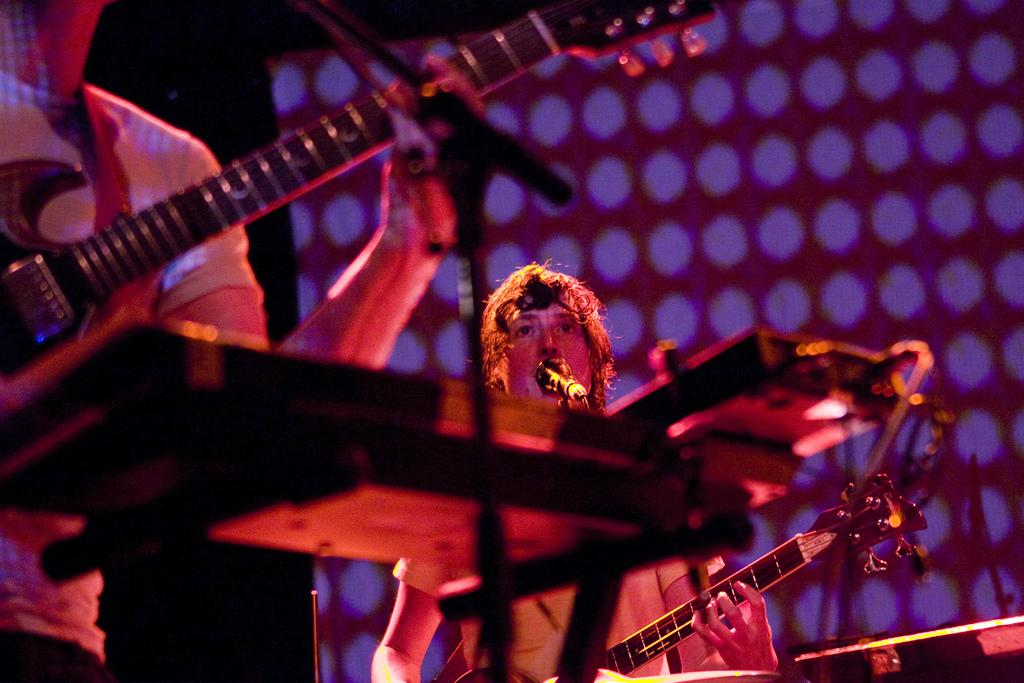How many people are in the image? There are two persons in the image. What are the persons doing in the image? The persons are standing and holding guitars. What object is in front of the persons? There is a microphone in front of the persons. What can be seen in the background of the image? There is a wall and light visible in the background of the image. What type of ornament is hanging from the cap of the person on the left? There is no cap or ornament present in the image. How low is the light in the background of the image? The light in the background of the image is not described in terms of height or distance, so it cannot be determined how low it is. 